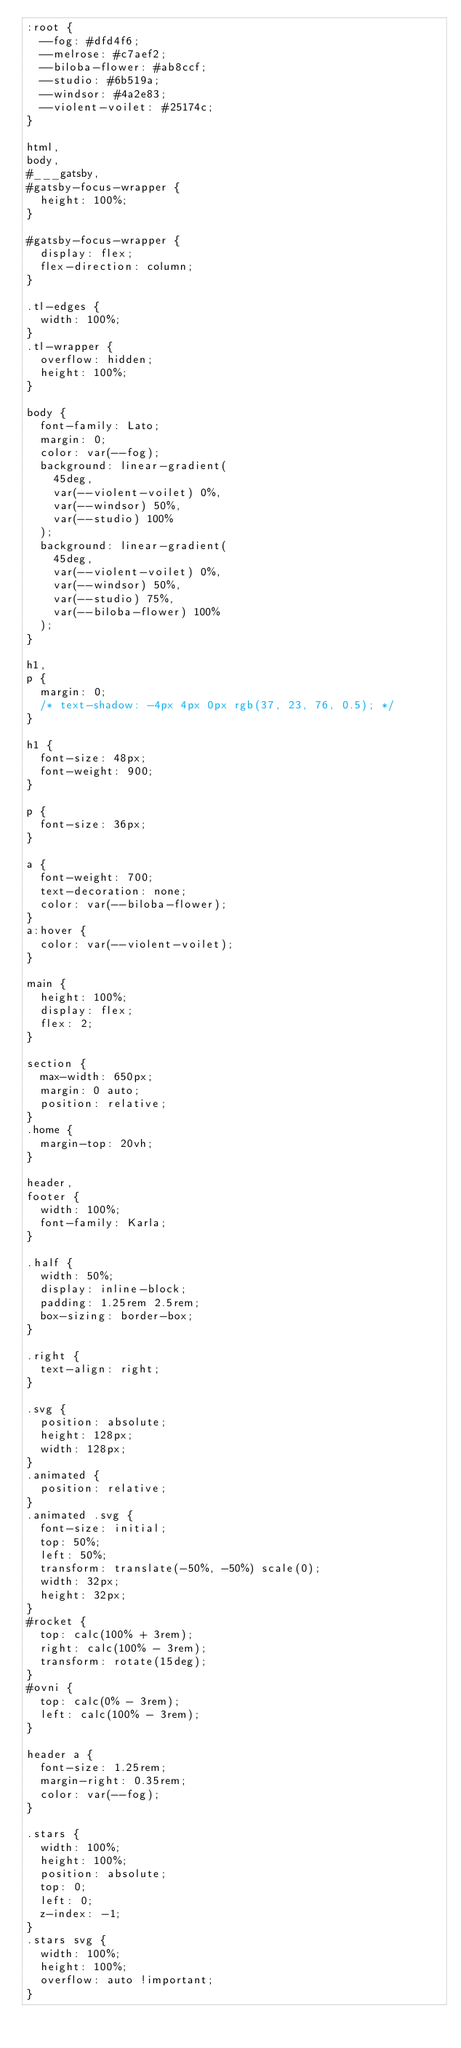<code> <loc_0><loc_0><loc_500><loc_500><_CSS_>:root {
  --fog: #dfd4f6;
  --melrose: #c7aef2;
  --biloba-flower: #ab8ccf;
  --studio: #6b519a;
  --windsor: #4a2e83;
  --violent-voilet: #25174c;
}

html,
body,
#___gatsby,
#gatsby-focus-wrapper {
  height: 100%;
}

#gatsby-focus-wrapper {
  display: flex;
  flex-direction: column;
}

.tl-edges {
  width: 100%;
}
.tl-wrapper {
  overflow: hidden;
  height: 100%;
}

body {
  font-family: Lato;
  margin: 0;
  color: var(--fog);
  background: linear-gradient(
    45deg,
    var(--violent-voilet) 0%,
    var(--windsor) 50%,
    var(--studio) 100%
  );
  background: linear-gradient(
    45deg,
    var(--violent-voilet) 0%,
    var(--windsor) 50%,
    var(--studio) 75%,
    var(--biloba-flower) 100%
  );
}

h1,
p {
  margin: 0;
  /* text-shadow: -4px 4px 0px rgb(37, 23, 76, 0.5); */
}

h1 {
  font-size: 48px;
  font-weight: 900;
}

p {
  font-size: 36px;
}

a {
  font-weight: 700;
  text-decoration: none;
  color: var(--biloba-flower);
}
a:hover {
  color: var(--violent-voilet);
}

main {
  height: 100%;
  display: flex;
  flex: 2;
}

section {
  max-width: 650px;
  margin: 0 auto;
  position: relative;
}
.home {
  margin-top: 20vh;
}

header,
footer {
  width: 100%;
  font-family: Karla;
}

.half {
  width: 50%;
  display: inline-block;
  padding: 1.25rem 2.5rem;
  box-sizing: border-box;
}

.right {
  text-align: right;
}

.svg {
  position: absolute;
  height: 128px;
  width: 128px;
}
.animated {
  position: relative;
}
.animated .svg {
  font-size: initial;
  top: 50%;
  left: 50%;
  transform: translate(-50%, -50%) scale(0);
  width: 32px;
  height: 32px;
}
#rocket {
  top: calc(100% + 3rem);
  right: calc(100% - 3rem);
  transform: rotate(15deg);
}
#ovni {
  top: calc(0% - 3rem);
  left: calc(100% - 3rem);
}

header a {
  font-size: 1.25rem;
  margin-right: 0.35rem;
  color: var(--fog);
}

.stars {
  width: 100%;
  height: 100%;
  position: absolute;
  top: 0;
  left: 0;
  z-index: -1;
}
.stars svg {
  width: 100%;
  height: 100%;
  overflow: auto !important;
}
</code> 